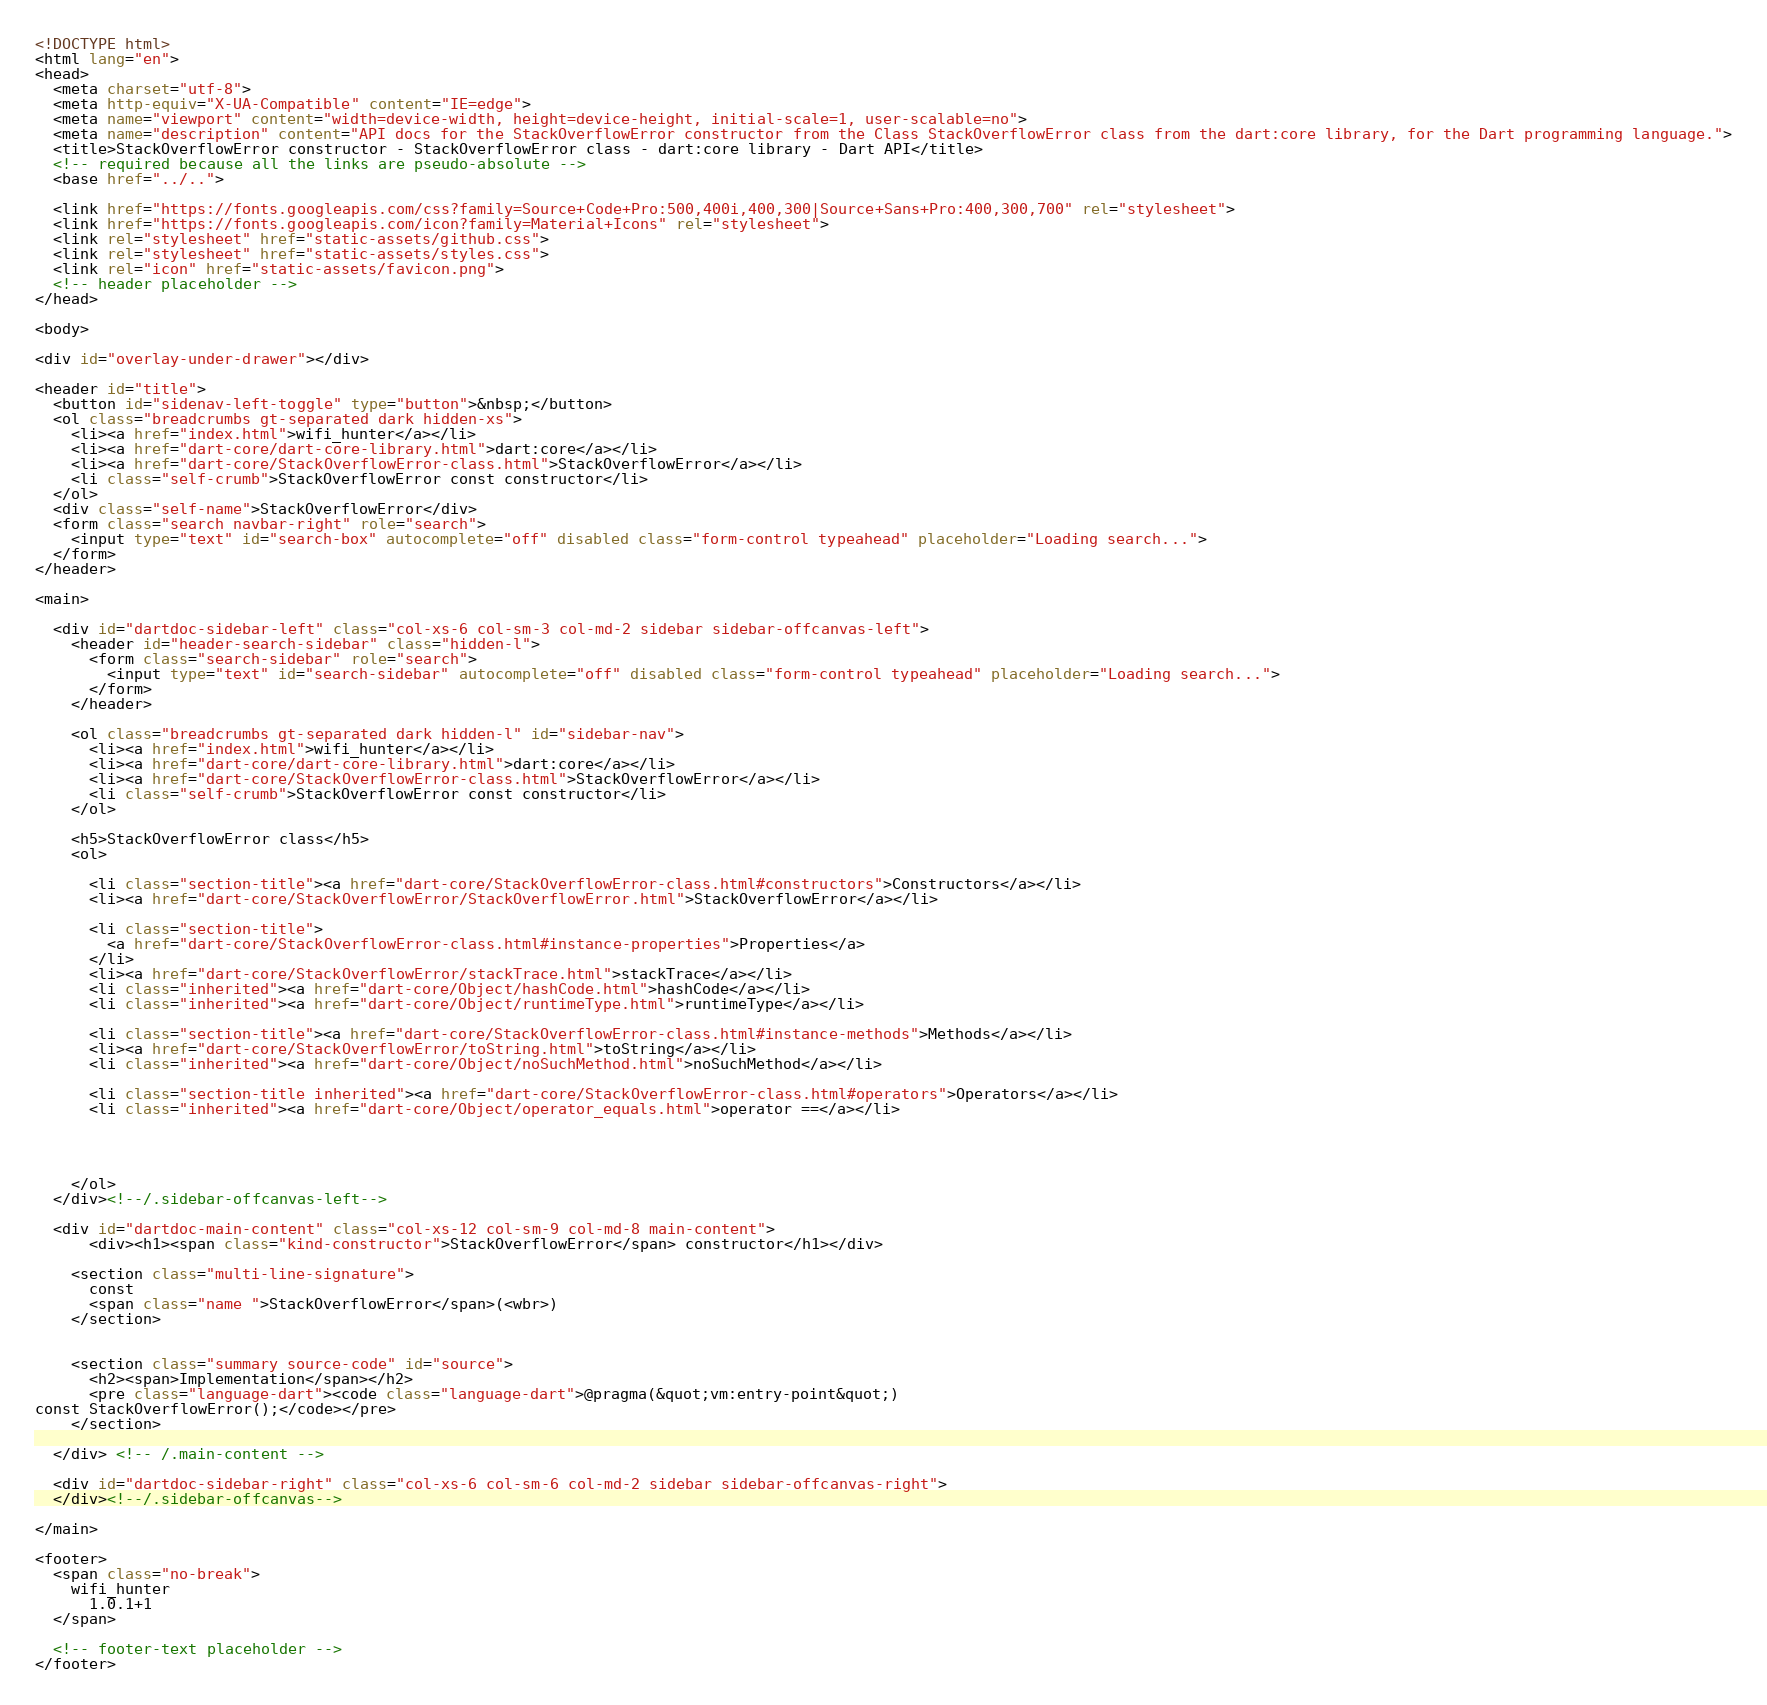<code> <loc_0><loc_0><loc_500><loc_500><_HTML_><!DOCTYPE html>
<html lang="en">
<head>
  <meta charset="utf-8">
  <meta http-equiv="X-UA-Compatible" content="IE=edge">
  <meta name="viewport" content="width=device-width, height=device-height, initial-scale=1, user-scalable=no">
  <meta name="description" content="API docs for the StackOverflowError constructor from the Class StackOverflowError class from the dart:core library, for the Dart programming language.">
  <title>StackOverflowError constructor - StackOverflowError class - dart:core library - Dart API</title>
  <!-- required because all the links are pseudo-absolute -->
  <base href="../..">

  <link href="https://fonts.googleapis.com/css?family=Source+Code+Pro:500,400i,400,300|Source+Sans+Pro:400,300,700" rel="stylesheet">
  <link href="https://fonts.googleapis.com/icon?family=Material+Icons" rel="stylesheet">
  <link rel="stylesheet" href="static-assets/github.css">
  <link rel="stylesheet" href="static-assets/styles.css">
  <link rel="icon" href="static-assets/favicon.png">
  <!-- header placeholder -->
</head>

<body>

<div id="overlay-under-drawer"></div>

<header id="title">
  <button id="sidenav-left-toggle" type="button">&nbsp;</button>
  <ol class="breadcrumbs gt-separated dark hidden-xs">
    <li><a href="index.html">wifi_hunter</a></li>
    <li><a href="dart-core/dart-core-library.html">dart:core</a></li>
    <li><a href="dart-core/StackOverflowError-class.html">StackOverflowError</a></li>
    <li class="self-crumb">StackOverflowError const constructor</li>
  </ol>
  <div class="self-name">StackOverflowError</div>
  <form class="search navbar-right" role="search">
    <input type="text" id="search-box" autocomplete="off" disabled class="form-control typeahead" placeholder="Loading search...">
  </form>
</header>

<main>

  <div id="dartdoc-sidebar-left" class="col-xs-6 col-sm-3 col-md-2 sidebar sidebar-offcanvas-left">
    <header id="header-search-sidebar" class="hidden-l">
      <form class="search-sidebar" role="search">
        <input type="text" id="search-sidebar" autocomplete="off" disabled class="form-control typeahead" placeholder="Loading search...">
      </form>
    </header>
    
    <ol class="breadcrumbs gt-separated dark hidden-l" id="sidebar-nav">
      <li><a href="index.html">wifi_hunter</a></li>
      <li><a href="dart-core/dart-core-library.html">dart:core</a></li>
      <li><a href="dart-core/StackOverflowError-class.html">StackOverflowError</a></li>
      <li class="self-crumb">StackOverflowError const constructor</li>
    </ol>
    
    <h5>StackOverflowError class</h5>
    <ol>
    
      <li class="section-title"><a href="dart-core/StackOverflowError-class.html#constructors">Constructors</a></li>
      <li><a href="dart-core/StackOverflowError/StackOverflowError.html">StackOverflowError</a></li>
    
      <li class="section-title">
        <a href="dart-core/StackOverflowError-class.html#instance-properties">Properties</a>
      </li>
      <li><a href="dart-core/StackOverflowError/stackTrace.html">stackTrace</a></li>
      <li class="inherited"><a href="dart-core/Object/hashCode.html">hashCode</a></li>
      <li class="inherited"><a href="dart-core/Object/runtimeType.html">runtimeType</a></li>
    
      <li class="section-title"><a href="dart-core/StackOverflowError-class.html#instance-methods">Methods</a></li>
      <li><a href="dart-core/StackOverflowError/toString.html">toString</a></li>
      <li class="inherited"><a href="dart-core/Object/noSuchMethod.html">noSuchMethod</a></li>
    
      <li class="section-title inherited"><a href="dart-core/StackOverflowError-class.html#operators">Operators</a></li>
      <li class="inherited"><a href="dart-core/Object/operator_equals.html">operator ==</a></li>
    
    
    
    
    </ol>
  </div><!--/.sidebar-offcanvas-left-->

  <div id="dartdoc-main-content" class="col-xs-12 col-sm-9 col-md-8 main-content">
      <div><h1><span class="kind-constructor">StackOverflowError</span> constructor</h1></div>

    <section class="multi-line-signature">
      const
      <span class="name ">StackOverflowError</span>(<wbr>)
    </section>

    
    <section class="summary source-code" id="source">
      <h2><span>Implementation</span></h2>
      <pre class="language-dart"><code class="language-dart">@pragma(&quot;vm:entry-point&quot;)
const StackOverflowError();</code></pre>
    </section>

  </div> <!-- /.main-content -->

  <div id="dartdoc-sidebar-right" class="col-xs-6 col-sm-6 col-md-2 sidebar sidebar-offcanvas-right">
  </div><!--/.sidebar-offcanvas-->

</main>

<footer>
  <span class="no-break">
    wifi_hunter
      1.0.1+1
  </span>

  <!-- footer-text placeholder -->
</footer>
</code> 